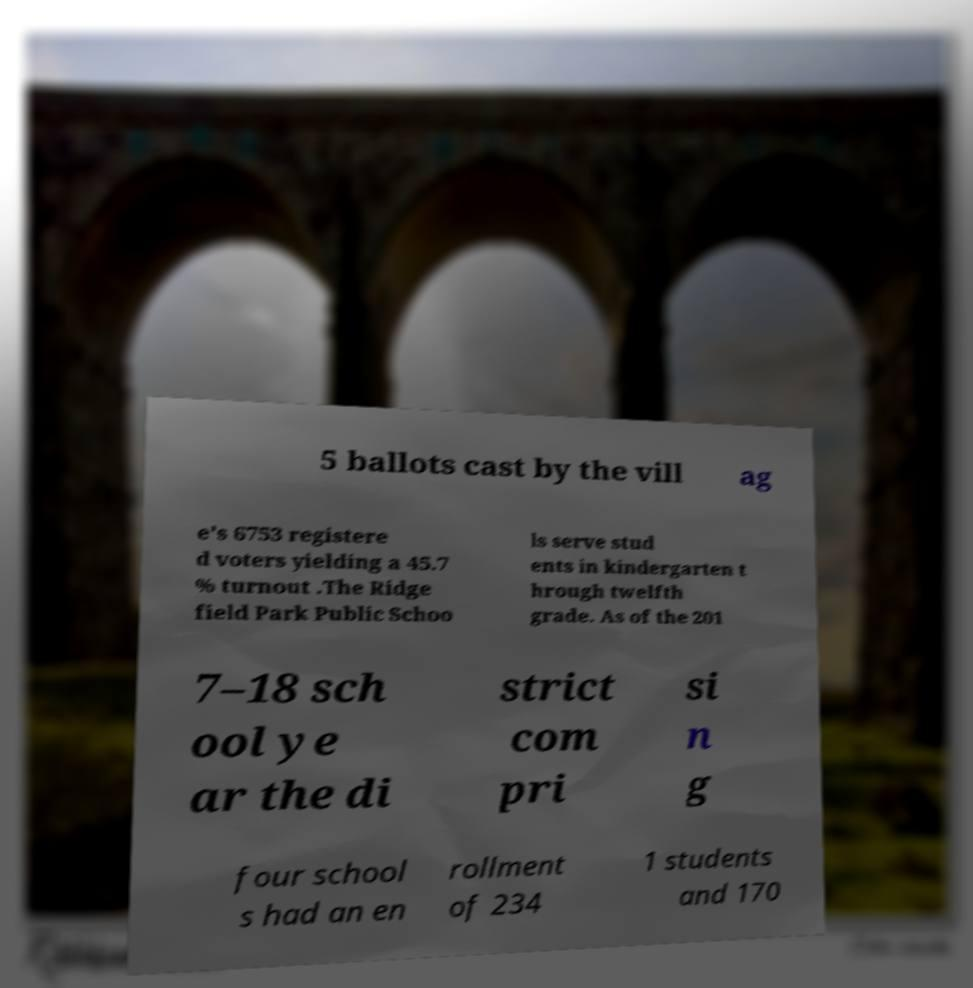Can you accurately transcribe the text from the provided image for me? 5 ballots cast by the vill ag e's 6753 registere d voters yielding a 45.7 % turnout .The Ridge field Park Public Schoo ls serve stud ents in kindergarten t hrough twelfth grade. As of the 201 7–18 sch ool ye ar the di strict com pri si n g four school s had an en rollment of 234 1 students and 170 